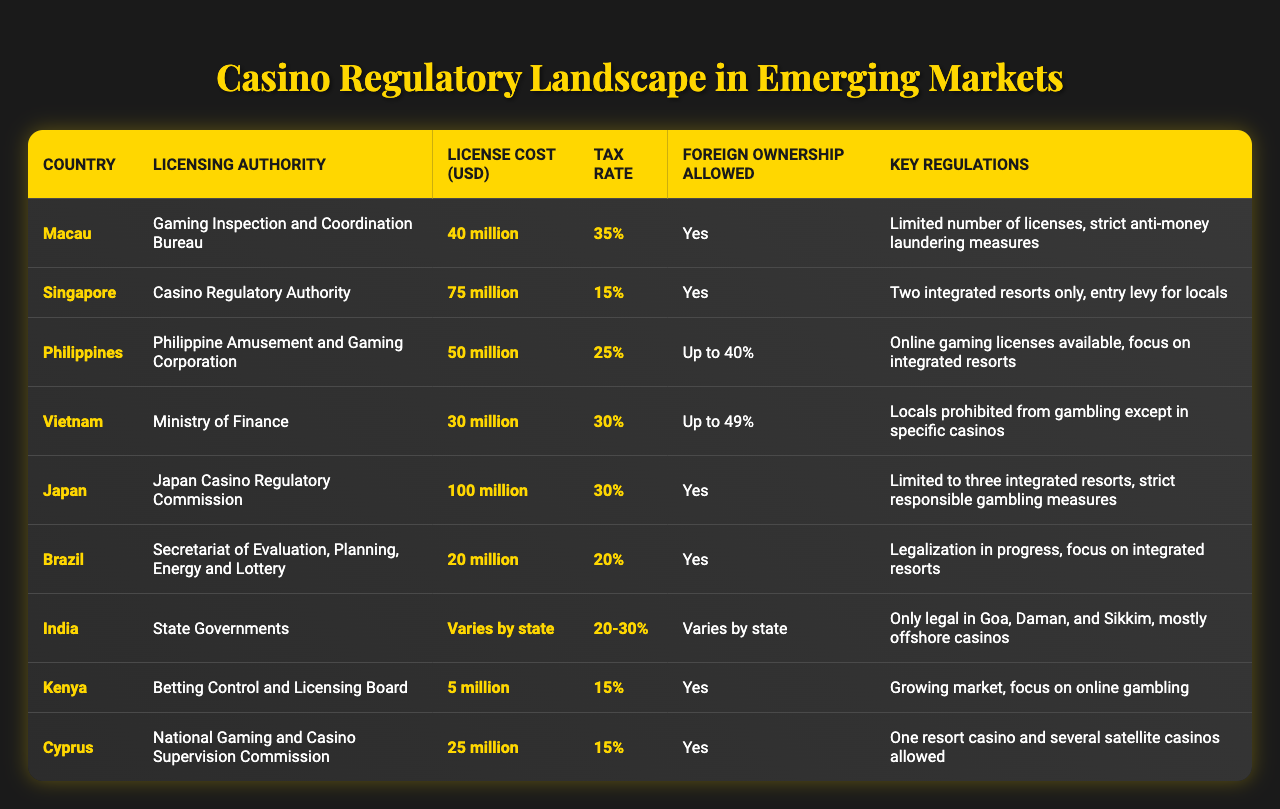What is the licensing authority for Singapore? The table indicates that the licensing authority for Singapore is the Casino Regulatory Authority.
Answer: Casino Regulatory Authority Which country has the highest license cost? The table shows that Japan has the highest license cost at 100 million USD.
Answer: 100 million USD Is foreign ownership allowed in Macau? According to the table, foreign ownership is allowed in Macau.
Answer: Yes What is the tax rate for Brazil? The tax rate listed for Brazil in the table is 20%.
Answer: 20% Which country prohibits locals from gambling except in specific casinos? The table states that Vietnam prohibits locals from gambling except in specific casinos.
Answer: Vietnam What is the average license cost of the countries listed? The average license cost can be calculated by adding all license costs (40 + 75 + 50 + 30 + 100 + 20 + 0 + 5 + 25 million) and dividing by the number of countries (8). Thus, the average is (40 + 75 + 50 + 30 + 100 + 20 + 0 + 5 + 25) / 8 = 30.625 million USD.
Answer: 30.625 million USD Which countries allow foreign ownership up to 49%? The countries that allow foreign ownership up to 49% as per the table are Vietnam.
Answer: Vietnam How many countries have a tax rate of 15%? From the table, two countries have a tax rate of 15%: Singapore and Kenya.
Answer: 2 Do all countries listed have a focus on integrated resorts? By checking the table, we see that all listed countries emphasize integrated resorts as part of their regulations, making this statement true.
Answer: Yes What is the difference in license costs between Japan and Kenya? The license cost for Japan is 100 million USD and for Kenya it's 5 million USD. The difference is 100 million - 5 million = 95 million USD.
Answer: 95 million USD Which country is in the process of legalization? According to the table, Brazil is currently in the process of legalization.
Answer: Brazil 